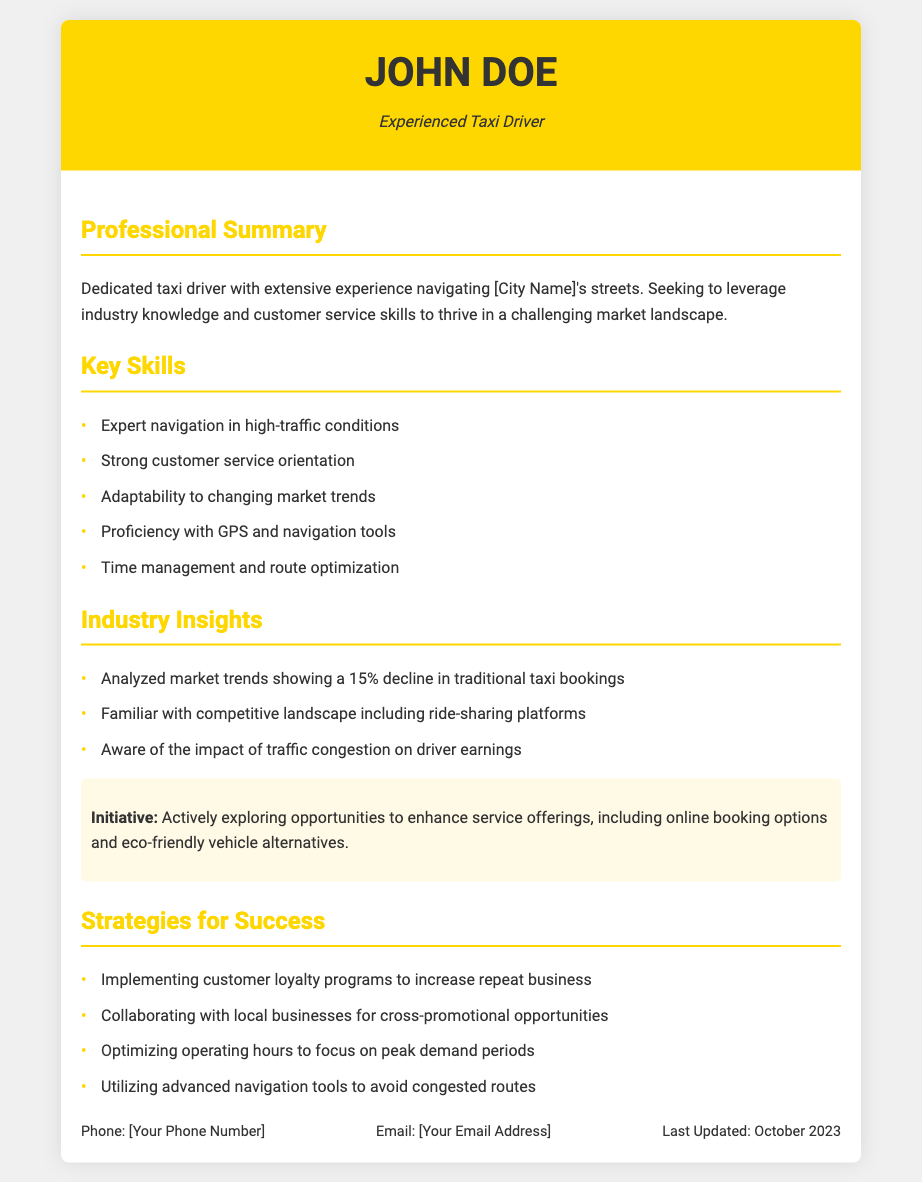What is the name of the taxi driver? The name of the taxi driver is provided in the header section of the resume, which is "John Doe."
Answer: John Doe What percentage decline was observed in traditional taxi bookings? The document states that there was a "15% decline in traditional taxi bookings."
Answer: 15% What is one technology mentioned that the taxi driver is proficient with? The document lists "GPS and navigation tools" as one of the driver's proficiencies.
Answer: GPS and navigation tools What initiative is the taxi driver actively exploring? The highlighted initiative in the document refers to enhancing service offerings, specifically "online booking options and eco-friendly vehicle alternatives."
Answer: online booking options and eco-friendly vehicle alternatives How many key skills are listed in the resume? The resume mentions five key skills in the respective section.
Answer: five What customer strategy is mentioned for increasing repeat business? The document lists "Implementing customer loyalty programs" as a strategy for enhancing repeat business.
Answer: Implementing customer loyalty programs What is the last updated date of the resume? The resume states that it was last updated in October 2023, as per the contact information section.
Answer: October 2023 What industry insight is related to traffic congestion? The resume indicates an awareness of "the impact of traffic congestion on driver earnings" as a relevant insight.
Answer: the impact of traffic congestion on driver earnings 